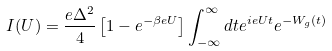Convert formula to latex. <formula><loc_0><loc_0><loc_500><loc_500>I ( U ) = \frac { e \Delta ^ { 2 } } { 4 } \left [ 1 - e ^ { - \beta e U } \right ] \int _ { - \infty } ^ { \infty } d t e ^ { i e U t } e ^ { - W _ { g } ( t ) }</formula> 